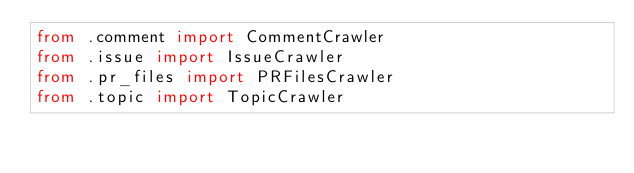<code> <loc_0><loc_0><loc_500><loc_500><_Python_>from .comment import CommentCrawler
from .issue import IssueCrawler
from .pr_files import PRFilesCrawler
from .topic import TopicCrawler
</code> 